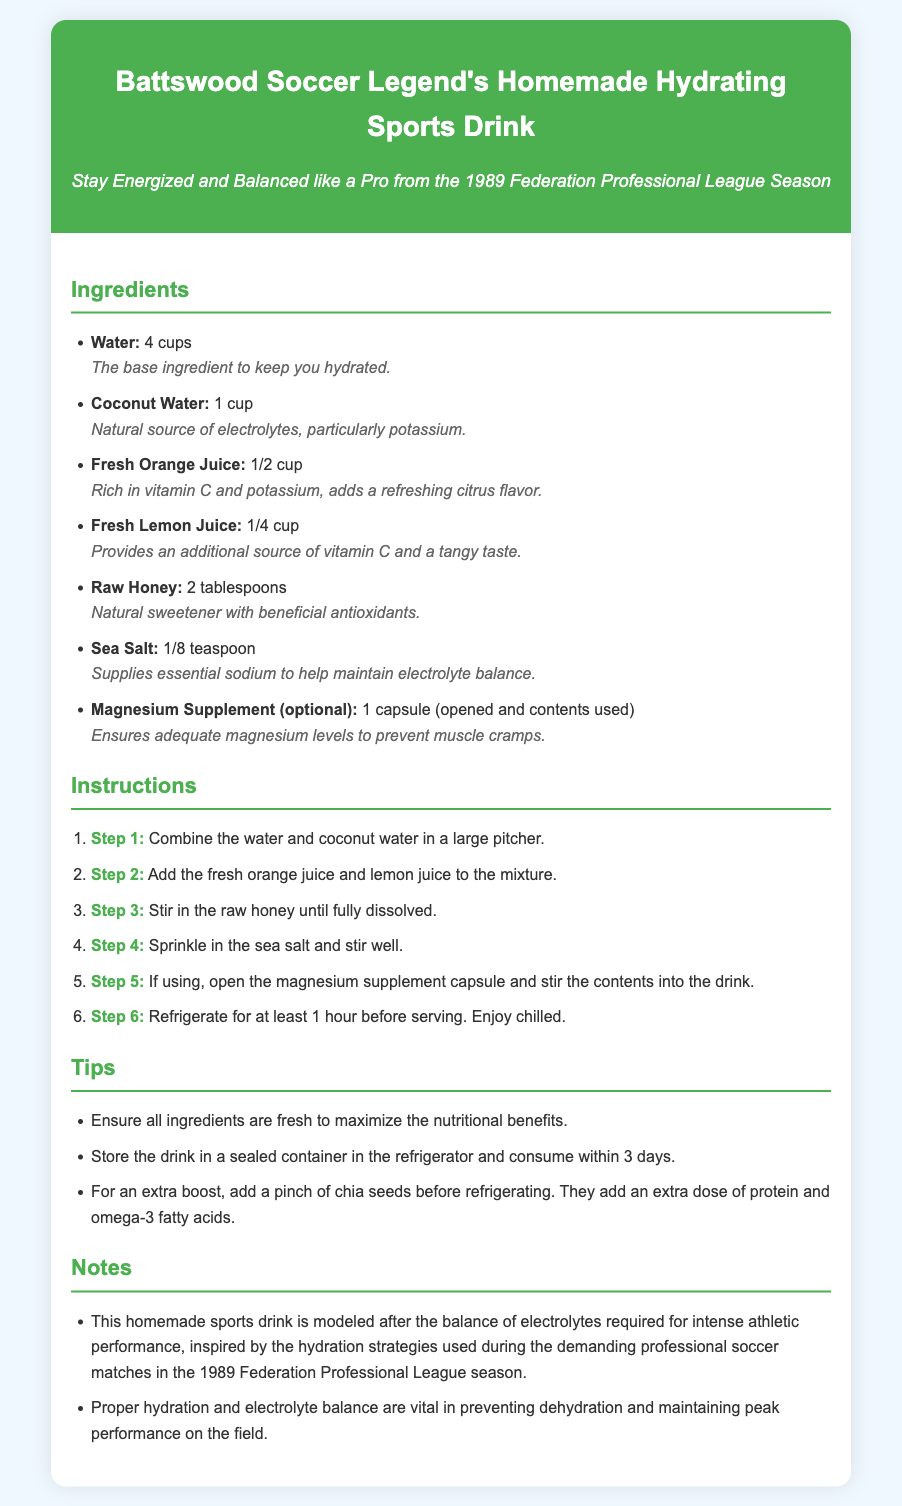What is the main title of the recipe? The title is displayed prominently at the top of the recipe card, summarizing its purpose and identity.
Answer: Battswood Soccer Legend's Homemade Hydrating Sports Drink How many cups of water are needed? This information is in the ingredient list, specifically stating the amount of water required for the drink.
Answer: 4 cups What is the optional ingredient included in the recipe? The recipe mentions an optional ingredient as a supplement to enhance the drink's effectiveness.
Answer: Magnesium Supplement How long should the drink be refrigerated before serving? The instructions detail the required chilling time to ensure the drink is served at the right temperature.
Answer: 1 hour What type of honey is used in the recipe? The ingredient list specifies the kind of sweetener added to the recipe for flavor and health benefits.
Answer: Raw Honey What are the benefits of coconut water mentioned? The notes after the ingredient suggest its importance and health benefits directly related to the drink.
Answer: Natural source of electrolytes, particularly potassium What is a suggested storage duration for the drink? This is included in the tips, which provide advice on how to keep the sports drink fresh after preparation.
Answer: 3 days What is one of the tips for enhancing the drink's nutritional value? This is a recommendation included to customize the drink further for health-conscious individuals.
Answer: Add a pinch of chia seeds What is one of the aims of this homemade sports drink? The notes section outlines the purpose and relevance of this drink to athletes and their performance needs.
Answer: To prevent dehydration and maintain peak performance 